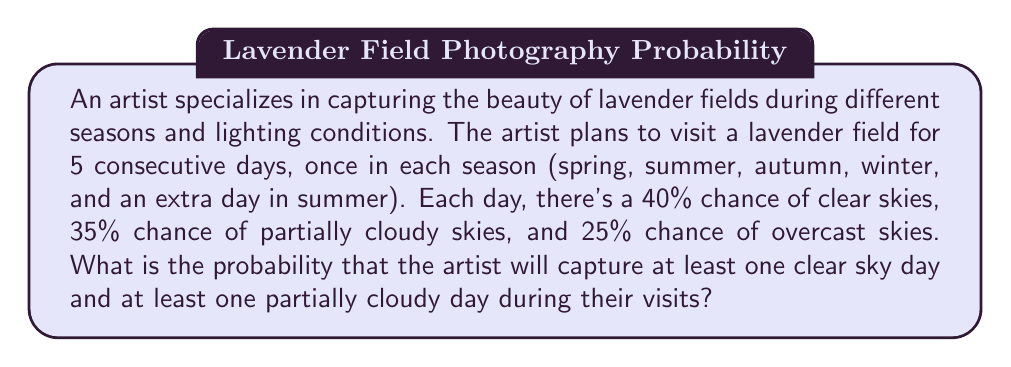Give your solution to this math problem. Let's approach this step-by-step:

1) First, let's calculate the probability of not getting a clear sky day in 5 visits:
   $P(\text{no clear sky}) = (1 - 0.4)^5 = 0.6^5 = 0.07776$

2) Similarly, the probability of not getting a partially cloudy day in 5 visits:
   $P(\text{no partially cloudy}) = (1 - 0.35)^5 = 0.65^5 = 0.11602$

3) The probability of getting at least one clear sky day AND at least one partially cloudy day is the complement of the probability of either not getting a clear sky day OR not getting a partially cloudy day:

   $P(\text{at least one clear AND at least one partially cloudy}) = 1 - P(\text{no clear OR no partially cloudy})$

4) We can calculate $P(\text{no clear OR no partially cloudy})$ using the addition rule of probability:

   $P(\text{no clear OR no partially cloudy}) = P(\text{no clear}) + P(\text{no partially cloudy}) - P(\text{no clear AND no partially cloudy})$

5) We need to calculate $P(\text{no clear AND no partially cloudy})$:
   $P(\text{no clear AND no partially cloudy}) = 0.25^5 = 0.0009765625$

6) Now we can complete the calculation:
   $P(\text{no clear OR no partially cloudy}) = 0.07776 + 0.11602 - 0.0009765625 = 0.19280344$

7) Finally:
   $P(\text{at least one clear AND at least one partially cloudy}) = 1 - 0.19280344 = 0.80719656$
Answer: $\frac{80719656}{100000000} \approx 0.8072$ 